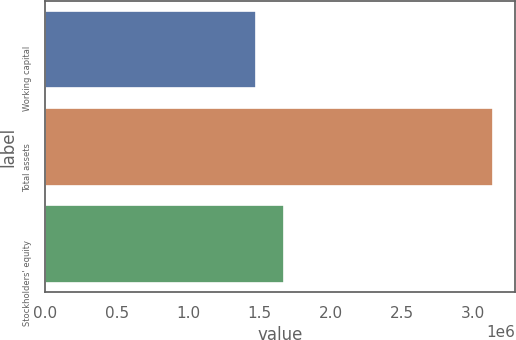<chart> <loc_0><loc_0><loc_500><loc_500><bar_chart><fcel>Working capital<fcel>Total assets<fcel>Stockholders' equity<nl><fcel>1.47953e+06<fcel>3.13711e+06<fcel>1.67182e+06<nl></chart> 